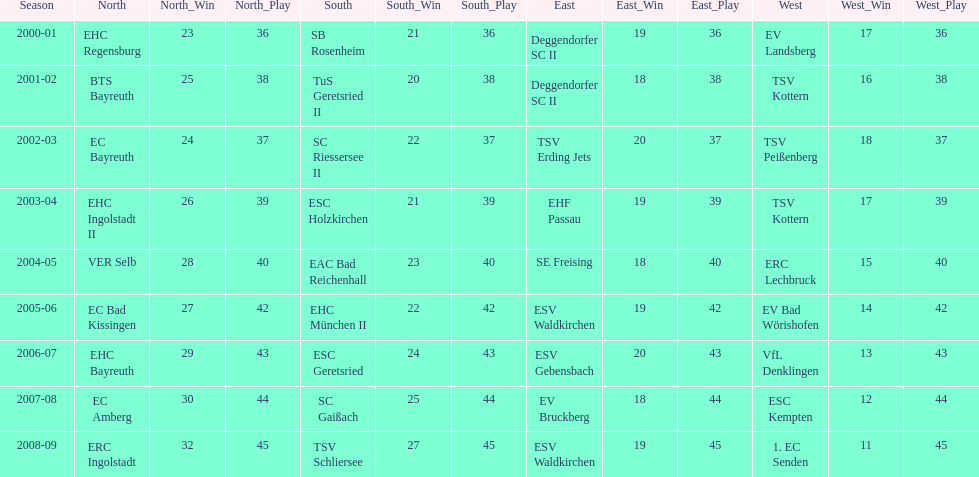Who won the season in the north before ec bayreuth did in 2002-03? BTS Bayreuth. 